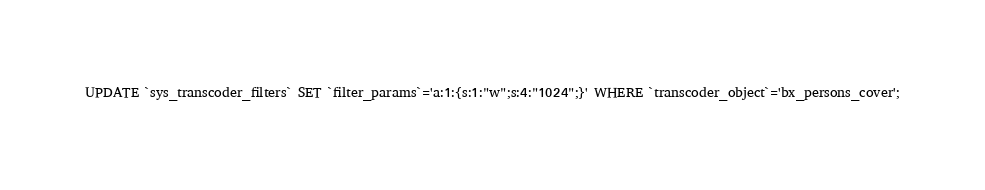<code> <loc_0><loc_0><loc_500><loc_500><_SQL_>UPDATE `sys_transcoder_filters` SET `filter_params`='a:1:{s:1:"w";s:4:"1024";}' WHERE `transcoder_object`='bx_persons_cover';</code> 